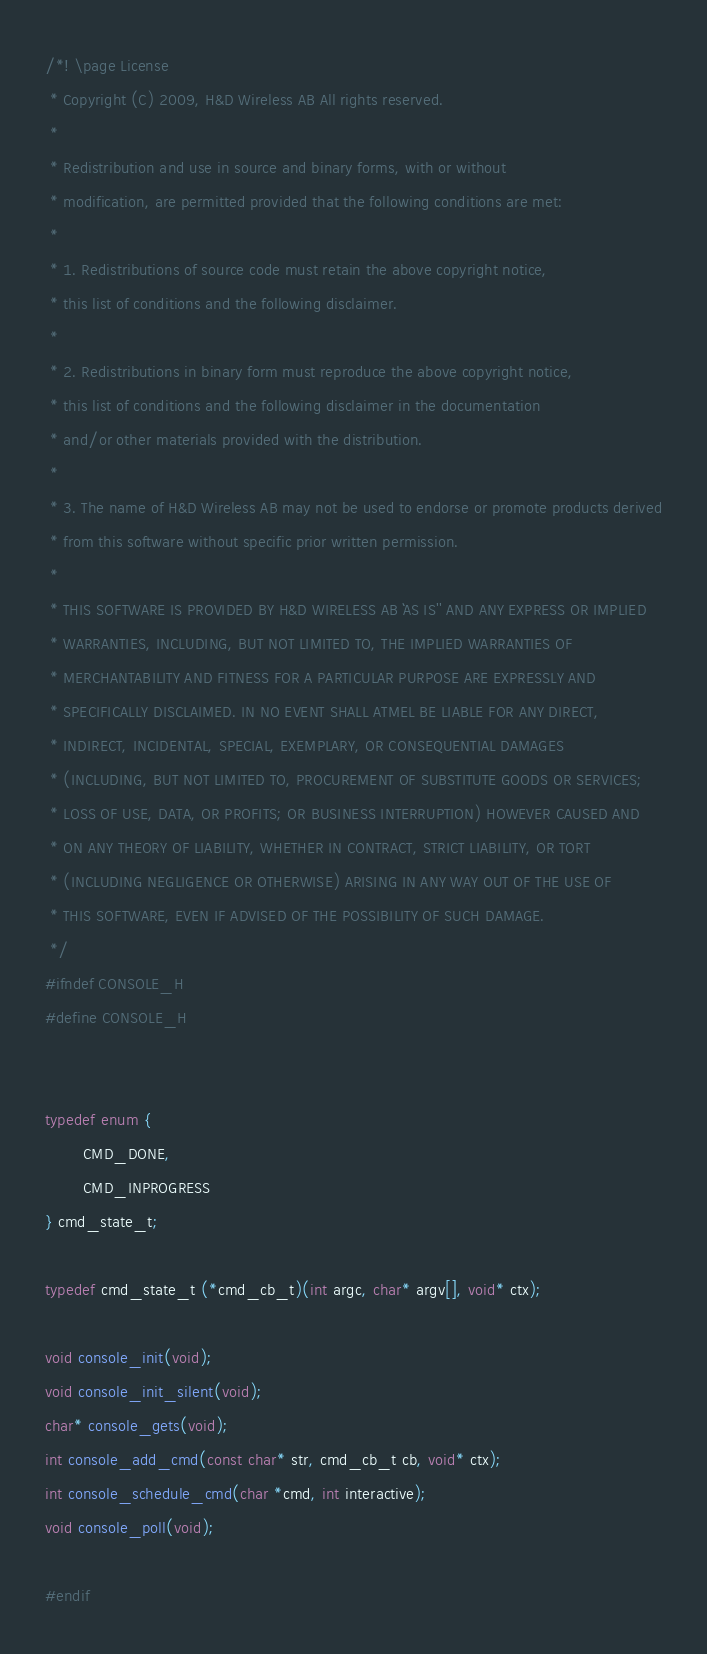<code> <loc_0><loc_0><loc_500><loc_500><_C_>/*! \page License
 * Copyright (C) 2009, H&D Wireless AB All rights reserved.
 *
 * Redistribution and use in source and binary forms, with or without
 * modification, are permitted provided that the following conditions are met:
 *
 * 1. Redistributions of source code must retain the above copyright notice,
 * this list of conditions and the following disclaimer.
 *
 * 2. Redistributions in binary form must reproduce the above copyright notice,
 * this list of conditions and the following disclaimer in the documentation
 * and/or other materials provided with the distribution.
 *
 * 3. The name of H&D Wireless AB may not be used to endorse or promote products derived
 * from this software without specific prior written permission.
 *
 * THIS SOFTWARE IS PROVIDED BY H&D WIRELESS AB ``AS IS'' AND ANY EXPRESS OR IMPLIED
 * WARRANTIES, INCLUDING, BUT NOT LIMITED TO, THE IMPLIED WARRANTIES OF
 * MERCHANTABILITY AND FITNESS FOR A PARTICULAR PURPOSE ARE EXPRESSLY AND
 * SPECIFICALLY DISCLAIMED. IN NO EVENT SHALL ATMEL BE LIABLE FOR ANY DIRECT,
 * INDIRECT, INCIDENTAL, SPECIAL, EXEMPLARY, OR CONSEQUENTIAL DAMAGES
 * (INCLUDING, BUT NOT LIMITED TO, PROCUREMENT OF SUBSTITUTE GOODS OR SERVICES;
 * LOSS OF USE, DATA, OR PROFITS; OR BUSINESS INTERRUPTION) HOWEVER CAUSED AND
 * ON ANY THEORY OF LIABILITY, WHETHER IN CONTRACT, STRICT LIABILITY, OR TORT
 * (INCLUDING NEGLIGENCE OR OTHERWISE) ARISING IN ANY WAY OUT OF THE USE OF
 * THIS SOFTWARE, EVEN IF ADVISED OF THE POSSIBILITY OF SUCH DAMAGE.
 */
#ifndef CONSOLE_H
#define CONSOLE_H


typedef enum {
        CMD_DONE,
        CMD_INPROGRESS
} cmd_state_t;

typedef cmd_state_t (*cmd_cb_t)(int argc, char* argv[], void* ctx);

void console_init(void);
void console_init_silent(void);
char* console_gets(void);
int console_add_cmd(const char* str, cmd_cb_t cb, void* ctx);
int console_schedule_cmd(char *cmd, int interactive);
void console_poll(void);

#endif
</code> 